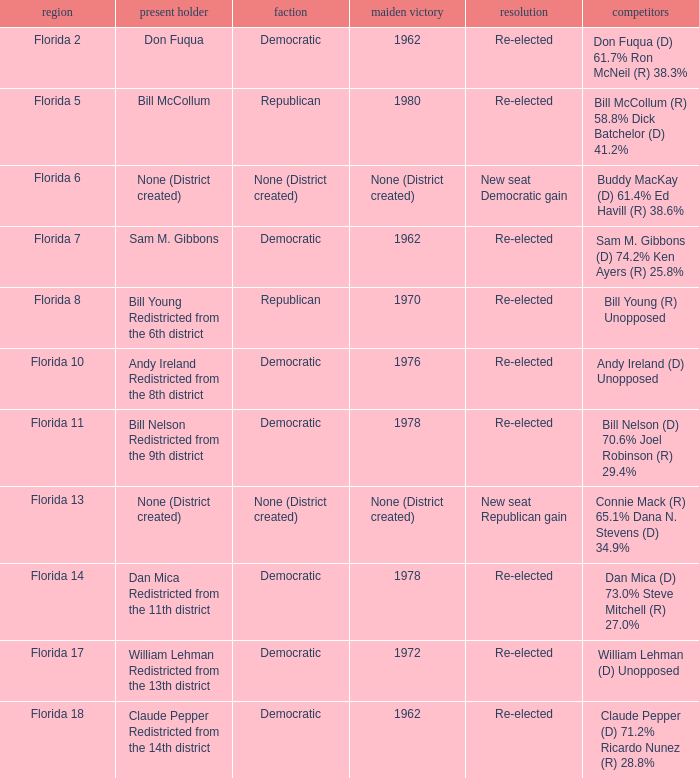 how many candidates with result being new seat democratic gain 1.0. 